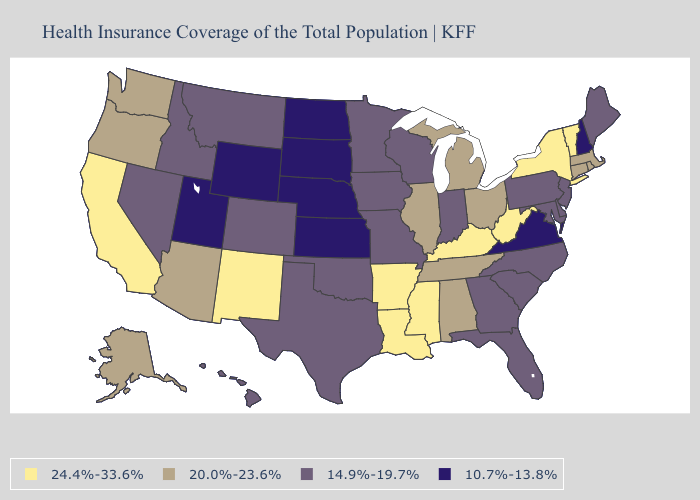What is the value of Louisiana?
Short answer required. 24.4%-33.6%. Which states have the lowest value in the South?
Be succinct. Virginia. What is the lowest value in states that border Idaho?
Give a very brief answer. 10.7%-13.8%. What is the value of Vermont?
Give a very brief answer. 24.4%-33.6%. Among the states that border New Jersey , which have the lowest value?
Short answer required. Delaware, Pennsylvania. What is the value of Vermont?
Quick response, please. 24.4%-33.6%. Does Ohio have a higher value than Oregon?
Write a very short answer. No. Name the states that have a value in the range 20.0%-23.6%?
Short answer required. Alabama, Alaska, Arizona, Connecticut, Illinois, Massachusetts, Michigan, Ohio, Oregon, Rhode Island, Tennessee, Washington. What is the lowest value in states that border Connecticut?
Quick response, please. 20.0%-23.6%. What is the highest value in states that border Massachusetts?
Concise answer only. 24.4%-33.6%. What is the value of Massachusetts?
Give a very brief answer. 20.0%-23.6%. Does Nevada have the lowest value in the USA?
Write a very short answer. No. What is the highest value in the West ?
Give a very brief answer. 24.4%-33.6%. What is the value of North Dakota?
Quick response, please. 10.7%-13.8%. What is the value of Louisiana?
Be succinct. 24.4%-33.6%. 